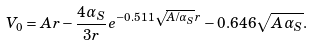<formula> <loc_0><loc_0><loc_500><loc_500>V _ { 0 } = A r - \frac { 4 \alpha _ { S } } { 3 r } e ^ { - 0 . 5 1 1 \sqrt { A / \alpha _ { S } } r } - 0 . 6 4 6 \sqrt { A \alpha _ { S } } .</formula> 